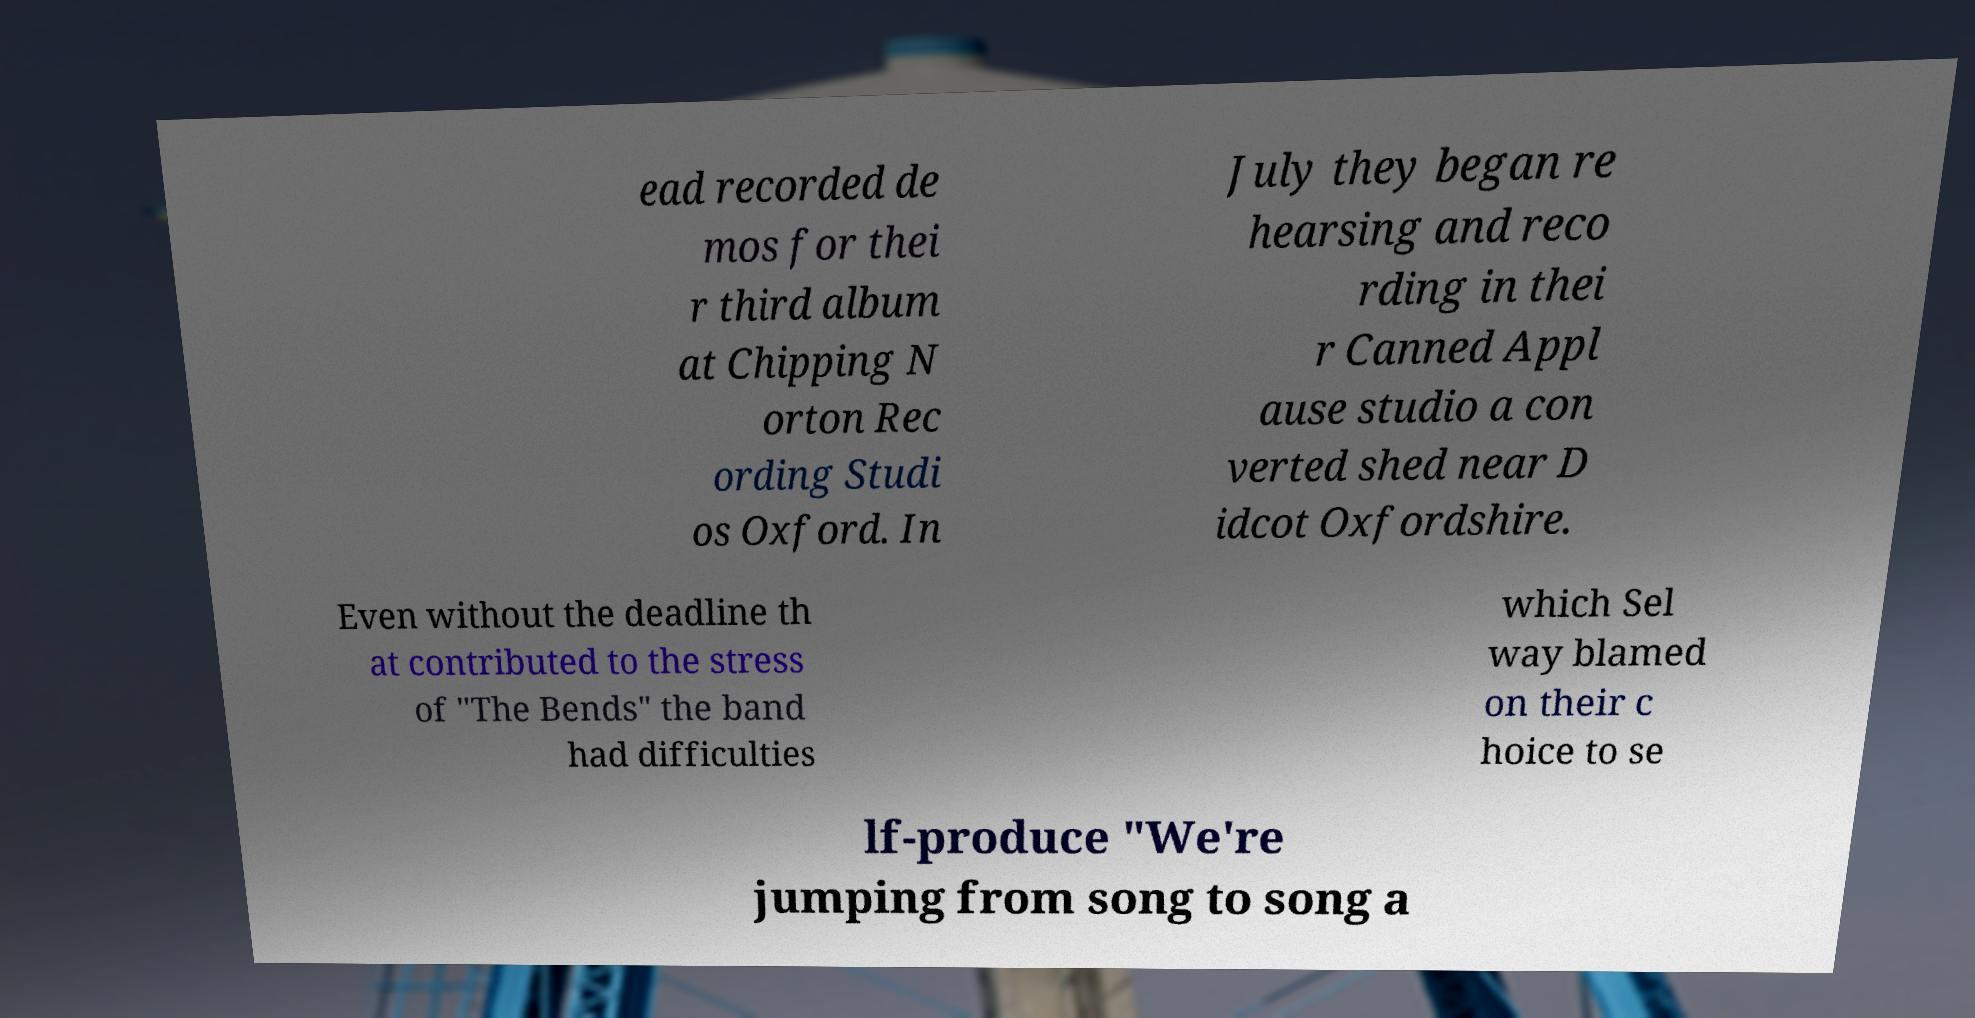Please identify and transcribe the text found in this image. ead recorded de mos for thei r third album at Chipping N orton Rec ording Studi os Oxford. In July they began re hearsing and reco rding in thei r Canned Appl ause studio a con verted shed near D idcot Oxfordshire. Even without the deadline th at contributed to the stress of "The Bends" the band had difficulties which Sel way blamed on their c hoice to se lf-produce "We're jumping from song to song a 